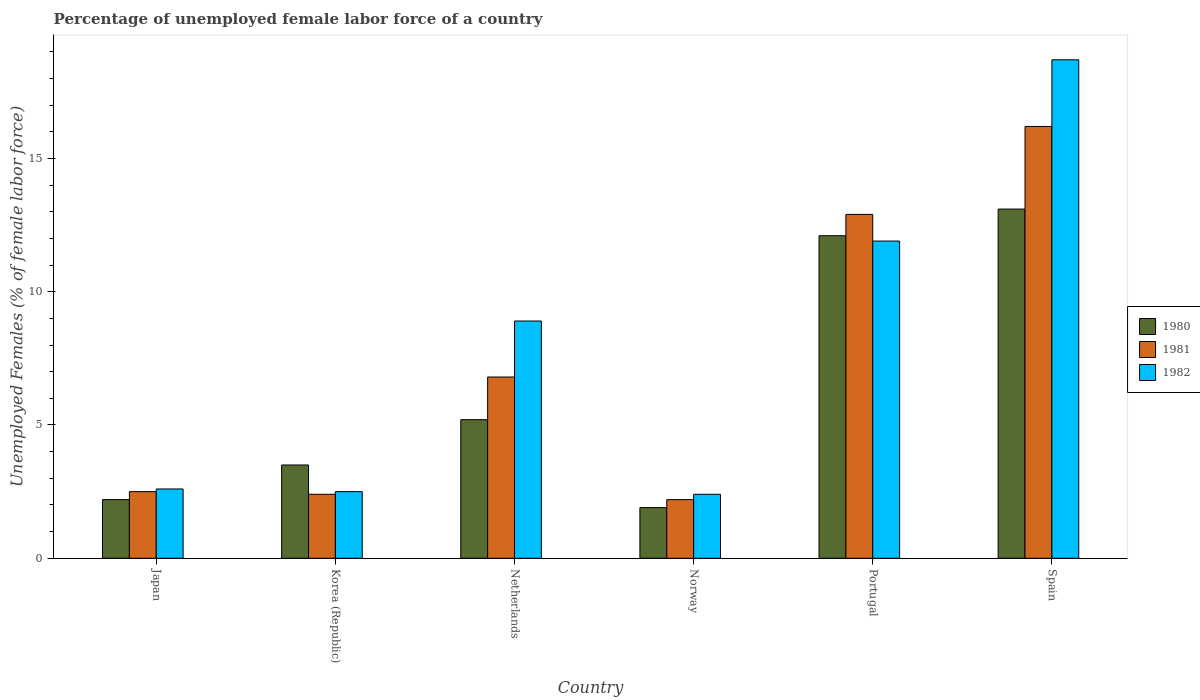Are the number of bars per tick equal to the number of legend labels?
Provide a short and direct response. Yes. How many bars are there on the 4th tick from the left?
Ensure brevity in your answer.  3. How many bars are there on the 4th tick from the right?
Offer a very short reply. 3. What is the label of the 2nd group of bars from the left?
Your response must be concise. Korea (Republic). What is the percentage of unemployed female labor force in 1980 in Spain?
Your answer should be very brief. 13.1. Across all countries, what is the maximum percentage of unemployed female labor force in 1982?
Your answer should be very brief. 18.7. Across all countries, what is the minimum percentage of unemployed female labor force in 1982?
Offer a terse response. 2.4. What is the total percentage of unemployed female labor force in 1980 in the graph?
Give a very brief answer. 38. What is the difference between the percentage of unemployed female labor force in 1982 in Korea (Republic) and that in Norway?
Your response must be concise. 0.1. What is the difference between the percentage of unemployed female labor force in 1981 in Spain and the percentage of unemployed female labor force in 1982 in Netherlands?
Make the answer very short. 7.3. What is the average percentage of unemployed female labor force in 1980 per country?
Your answer should be very brief. 6.33. What is the difference between the percentage of unemployed female labor force of/in 1980 and percentage of unemployed female labor force of/in 1982 in Norway?
Give a very brief answer. -0.5. In how many countries, is the percentage of unemployed female labor force in 1981 greater than 15 %?
Your answer should be very brief. 1. What is the ratio of the percentage of unemployed female labor force in 1980 in Japan to that in Netherlands?
Make the answer very short. 0.42. Is the percentage of unemployed female labor force in 1982 in Korea (Republic) less than that in Netherlands?
Offer a very short reply. Yes. Is the difference between the percentage of unemployed female labor force in 1980 in Korea (Republic) and Portugal greater than the difference between the percentage of unemployed female labor force in 1982 in Korea (Republic) and Portugal?
Offer a very short reply. Yes. What is the difference between the highest and the second highest percentage of unemployed female labor force in 1980?
Offer a terse response. -6.9. What is the difference between the highest and the lowest percentage of unemployed female labor force in 1981?
Provide a succinct answer. 14. In how many countries, is the percentage of unemployed female labor force in 1981 greater than the average percentage of unemployed female labor force in 1981 taken over all countries?
Make the answer very short. 2. Is the sum of the percentage of unemployed female labor force in 1981 in Norway and Portugal greater than the maximum percentage of unemployed female labor force in 1980 across all countries?
Provide a short and direct response. Yes. What does the 3rd bar from the left in Norway represents?
Make the answer very short. 1982. How many bars are there?
Your response must be concise. 18. How many countries are there in the graph?
Provide a succinct answer. 6. What is the difference between two consecutive major ticks on the Y-axis?
Offer a terse response. 5. Does the graph contain grids?
Your response must be concise. No. Where does the legend appear in the graph?
Offer a very short reply. Center right. What is the title of the graph?
Your answer should be very brief. Percentage of unemployed female labor force of a country. What is the label or title of the X-axis?
Provide a short and direct response. Country. What is the label or title of the Y-axis?
Keep it short and to the point. Unemployed Females (% of female labor force). What is the Unemployed Females (% of female labor force) in 1980 in Japan?
Your answer should be very brief. 2.2. What is the Unemployed Females (% of female labor force) of 1981 in Japan?
Make the answer very short. 2.5. What is the Unemployed Females (% of female labor force) in 1982 in Japan?
Your answer should be very brief. 2.6. What is the Unemployed Females (% of female labor force) of 1981 in Korea (Republic)?
Your response must be concise. 2.4. What is the Unemployed Females (% of female labor force) in 1980 in Netherlands?
Ensure brevity in your answer.  5.2. What is the Unemployed Females (% of female labor force) in 1981 in Netherlands?
Your answer should be very brief. 6.8. What is the Unemployed Females (% of female labor force) of 1982 in Netherlands?
Keep it short and to the point. 8.9. What is the Unemployed Females (% of female labor force) of 1980 in Norway?
Provide a succinct answer. 1.9. What is the Unemployed Females (% of female labor force) in 1981 in Norway?
Offer a very short reply. 2.2. What is the Unemployed Females (% of female labor force) of 1982 in Norway?
Offer a terse response. 2.4. What is the Unemployed Females (% of female labor force) of 1980 in Portugal?
Make the answer very short. 12.1. What is the Unemployed Females (% of female labor force) of 1981 in Portugal?
Make the answer very short. 12.9. What is the Unemployed Females (% of female labor force) of 1982 in Portugal?
Offer a very short reply. 11.9. What is the Unemployed Females (% of female labor force) of 1980 in Spain?
Your answer should be compact. 13.1. What is the Unemployed Females (% of female labor force) of 1981 in Spain?
Ensure brevity in your answer.  16.2. What is the Unemployed Females (% of female labor force) of 1982 in Spain?
Your answer should be very brief. 18.7. Across all countries, what is the maximum Unemployed Females (% of female labor force) of 1980?
Offer a terse response. 13.1. Across all countries, what is the maximum Unemployed Females (% of female labor force) in 1981?
Keep it short and to the point. 16.2. Across all countries, what is the maximum Unemployed Females (% of female labor force) in 1982?
Make the answer very short. 18.7. Across all countries, what is the minimum Unemployed Females (% of female labor force) of 1980?
Give a very brief answer. 1.9. Across all countries, what is the minimum Unemployed Females (% of female labor force) in 1981?
Your answer should be very brief. 2.2. Across all countries, what is the minimum Unemployed Females (% of female labor force) in 1982?
Your response must be concise. 2.4. What is the total Unemployed Females (% of female labor force) of 1980 in the graph?
Give a very brief answer. 38. What is the total Unemployed Females (% of female labor force) in 1982 in the graph?
Provide a succinct answer. 47. What is the difference between the Unemployed Females (% of female labor force) of 1980 in Japan and that in Korea (Republic)?
Give a very brief answer. -1.3. What is the difference between the Unemployed Females (% of female labor force) in 1981 in Japan and that in Korea (Republic)?
Ensure brevity in your answer.  0.1. What is the difference between the Unemployed Females (% of female labor force) in 1980 in Japan and that in Netherlands?
Offer a very short reply. -3. What is the difference between the Unemployed Females (% of female labor force) of 1981 in Japan and that in Netherlands?
Your answer should be compact. -4.3. What is the difference between the Unemployed Females (% of female labor force) in 1982 in Japan and that in Netherlands?
Your answer should be compact. -6.3. What is the difference between the Unemployed Females (% of female labor force) of 1982 in Japan and that in Norway?
Keep it short and to the point. 0.2. What is the difference between the Unemployed Females (% of female labor force) in 1981 in Japan and that in Portugal?
Offer a terse response. -10.4. What is the difference between the Unemployed Females (% of female labor force) in 1981 in Japan and that in Spain?
Offer a terse response. -13.7. What is the difference between the Unemployed Females (% of female labor force) in 1982 in Japan and that in Spain?
Ensure brevity in your answer.  -16.1. What is the difference between the Unemployed Females (% of female labor force) of 1980 in Korea (Republic) and that in Netherlands?
Make the answer very short. -1.7. What is the difference between the Unemployed Females (% of female labor force) of 1982 in Korea (Republic) and that in Netherlands?
Ensure brevity in your answer.  -6.4. What is the difference between the Unemployed Females (% of female labor force) in 1980 in Korea (Republic) and that in Norway?
Your response must be concise. 1.6. What is the difference between the Unemployed Females (% of female labor force) in 1981 in Korea (Republic) and that in Norway?
Your answer should be very brief. 0.2. What is the difference between the Unemployed Females (% of female labor force) of 1982 in Korea (Republic) and that in Norway?
Offer a terse response. 0.1. What is the difference between the Unemployed Females (% of female labor force) in 1980 in Korea (Republic) and that in Portugal?
Give a very brief answer. -8.6. What is the difference between the Unemployed Females (% of female labor force) of 1982 in Korea (Republic) and that in Portugal?
Ensure brevity in your answer.  -9.4. What is the difference between the Unemployed Females (% of female labor force) in 1980 in Korea (Republic) and that in Spain?
Offer a very short reply. -9.6. What is the difference between the Unemployed Females (% of female labor force) in 1981 in Korea (Republic) and that in Spain?
Provide a succinct answer. -13.8. What is the difference between the Unemployed Females (% of female labor force) in 1982 in Korea (Republic) and that in Spain?
Your response must be concise. -16.2. What is the difference between the Unemployed Females (% of female labor force) of 1980 in Netherlands and that in Norway?
Keep it short and to the point. 3.3. What is the difference between the Unemployed Females (% of female labor force) of 1982 in Netherlands and that in Norway?
Provide a succinct answer. 6.5. What is the difference between the Unemployed Females (% of female labor force) in 1980 in Netherlands and that in Portugal?
Keep it short and to the point. -6.9. What is the difference between the Unemployed Females (% of female labor force) of 1980 in Netherlands and that in Spain?
Your answer should be compact. -7.9. What is the difference between the Unemployed Females (% of female labor force) of 1981 in Netherlands and that in Spain?
Ensure brevity in your answer.  -9.4. What is the difference between the Unemployed Females (% of female labor force) of 1982 in Netherlands and that in Spain?
Provide a succinct answer. -9.8. What is the difference between the Unemployed Females (% of female labor force) in 1982 in Norway and that in Spain?
Keep it short and to the point. -16.3. What is the difference between the Unemployed Females (% of female labor force) in 1980 in Portugal and that in Spain?
Your answer should be very brief. -1. What is the difference between the Unemployed Females (% of female labor force) in 1981 in Portugal and that in Spain?
Provide a succinct answer. -3.3. What is the difference between the Unemployed Females (% of female labor force) of 1980 in Japan and the Unemployed Females (% of female labor force) of 1981 in Korea (Republic)?
Your answer should be compact. -0.2. What is the difference between the Unemployed Females (% of female labor force) of 1980 in Japan and the Unemployed Females (% of female labor force) of 1982 in Korea (Republic)?
Your response must be concise. -0.3. What is the difference between the Unemployed Females (% of female labor force) in 1980 in Japan and the Unemployed Females (% of female labor force) in 1981 in Norway?
Ensure brevity in your answer.  0. What is the difference between the Unemployed Females (% of female labor force) in 1980 in Japan and the Unemployed Females (% of female labor force) in 1982 in Norway?
Give a very brief answer. -0.2. What is the difference between the Unemployed Females (% of female labor force) of 1981 in Japan and the Unemployed Females (% of female labor force) of 1982 in Norway?
Provide a succinct answer. 0.1. What is the difference between the Unemployed Females (% of female labor force) in 1980 in Japan and the Unemployed Females (% of female labor force) in 1981 in Portugal?
Give a very brief answer. -10.7. What is the difference between the Unemployed Females (% of female labor force) of 1980 in Japan and the Unemployed Females (% of female labor force) of 1982 in Portugal?
Offer a terse response. -9.7. What is the difference between the Unemployed Females (% of female labor force) in 1980 in Japan and the Unemployed Females (% of female labor force) in 1981 in Spain?
Your answer should be compact. -14. What is the difference between the Unemployed Females (% of female labor force) in 1980 in Japan and the Unemployed Females (% of female labor force) in 1982 in Spain?
Ensure brevity in your answer.  -16.5. What is the difference between the Unemployed Females (% of female labor force) in 1981 in Japan and the Unemployed Females (% of female labor force) in 1982 in Spain?
Your answer should be very brief. -16.2. What is the difference between the Unemployed Females (% of female labor force) in 1980 in Korea (Republic) and the Unemployed Females (% of female labor force) in 1982 in Netherlands?
Your response must be concise. -5.4. What is the difference between the Unemployed Females (% of female labor force) in 1981 in Korea (Republic) and the Unemployed Females (% of female labor force) in 1982 in Netherlands?
Offer a very short reply. -6.5. What is the difference between the Unemployed Females (% of female labor force) in 1980 in Korea (Republic) and the Unemployed Females (% of female labor force) in 1981 in Norway?
Make the answer very short. 1.3. What is the difference between the Unemployed Females (% of female labor force) in 1981 in Korea (Republic) and the Unemployed Females (% of female labor force) in 1982 in Norway?
Keep it short and to the point. 0. What is the difference between the Unemployed Females (% of female labor force) of 1980 in Korea (Republic) and the Unemployed Females (% of female labor force) of 1981 in Spain?
Your response must be concise. -12.7. What is the difference between the Unemployed Females (% of female labor force) in 1980 in Korea (Republic) and the Unemployed Females (% of female labor force) in 1982 in Spain?
Offer a very short reply. -15.2. What is the difference between the Unemployed Females (% of female labor force) in 1981 in Korea (Republic) and the Unemployed Females (% of female labor force) in 1982 in Spain?
Offer a terse response. -16.3. What is the difference between the Unemployed Females (% of female labor force) in 1980 in Netherlands and the Unemployed Females (% of female labor force) in 1982 in Norway?
Keep it short and to the point. 2.8. What is the difference between the Unemployed Females (% of female labor force) of 1981 in Netherlands and the Unemployed Females (% of female labor force) of 1982 in Norway?
Make the answer very short. 4.4. What is the difference between the Unemployed Females (% of female labor force) in 1980 in Netherlands and the Unemployed Females (% of female labor force) in 1981 in Portugal?
Give a very brief answer. -7.7. What is the difference between the Unemployed Females (% of female labor force) of 1981 in Netherlands and the Unemployed Females (% of female labor force) of 1982 in Portugal?
Make the answer very short. -5.1. What is the difference between the Unemployed Females (% of female labor force) in 1980 in Norway and the Unemployed Females (% of female labor force) in 1981 in Portugal?
Give a very brief answer. -11. What is the difference between the Unemployed Females (% of female labor force) in 1980 in Norway and the Unemployed Females (% of female labor force) in 1982 in Portugal?
Give a very brief answer. -10. What is the difference between the Unemployed Females (% of female labor force) of 1981 in Norway and the Unemployed Females (% of female labor force) of 1982 in Portugal?
Offer a very short reply. -9.7. What is the difference between the Unemployed Females (% of female labor force) in 1980 in Norway and the Unemployed Females (% of female labor force) in 1981 in Spain?
Your answer should be very brief. -14.3. What is the difference between the Unemployed Females (% of female labor force) of 1980 in Norway and the Unemployed Females (% of female labor force) of 1982 in Spain?
Provide a succinct answer. -16.8. What is the difference between the Unemployed Females (% of female labor force) of 1981 in Norway and the Unemployed Females (% of female labor force) of 1982 in Spain?
Your answer should be very brief. -16.5. What is the difference between the Unemployed Females (% of female labor force) in 1980 in Portugal and the Unemployed Females (% of female labor force) in 1982 in Spain?
Provide a succinct answer. -6.6. What is the difference between the Unemployed Females (% of female labor force) in 1981 in Portugal and the Unemployed Females (% of female labor force) in 1982 in Spain?
Your answer should be very brief. -5.8. What is the average Unemployed Females (% of female labor force) in 1980 per country?
Provide a short and direct response. 6.33. What is the average Unemployed Females (% of female labor force) in 1981 per country?
Provide a succinct answer. 7.17. What is the average Unemployed Females (% of female labor force) in 1982 per country?
Offer a very short reply. 7.83. What is the difference between the Unemployed Females (% of female labor force) in 1980 and Unemployed Females (% of female labor force) in 1982 in Japan?
Offer a terse response. -0.4. What is the difference between the Unemployed Females (% of female labor force) in 1981 and Unemployed Females (% of female labor force) in 1982 in Japan?
Offer a terse response. -0.1. What is the difference between the Unemployed Females (% of female labor force) in 1980 and Unemployed Females (% of female labor force) in 1981 in Korea (Republic)?
Offer a very short reply. 1.1. What is the difference between the Unemployed Females (% of female labor force) in 1980 and Unemployed Females (% of female labor force) in 1981 in Netherlands?
Make the answer very short. -1.6. What is the difference between the Unemployed Females (% of female labor force) in 1980 and Unemployed Females (% of female labor force) in 1982 in Netherlands?
Keep it short and to the point. -3.7. What is the difference between the Unemployed Females (% of female labor force) of 1981 and Unemployed Females (% of female labor force) of 1982 in Netherlands?
Your answer should be compact. -2.1. What is the difference between the Unemployed Females (% of female labor force) of 1980 and Unemployed Females (% of female labor force) of 1981 in Portugal?
Provide a succinct answer. -0.8. What is the ratio of the Unemployed Females (% of female labor force) in 1980 in Japan to that in Korea (Republic)?
Give a very brief answer. 0.63. What is the ratio of the Unemployed Females (% of female labor force) of 1981 in Japan to that in Korea (Republic)?
Your response must be concise. 1.04. What is the ratio of the Unemployed Females (% of female labor force) of 1982 in Japan to that in Korea (Republic)?
Your answer should be very brief. 1.04. What is the ratio of the Unemployed Females (% of female labor force) of 1980 in Japan to that in Netherlands?
Keep it short and to the point. 0.42. What is the ratio of the Unemployed Females (% of female labor force) in 1981 in Japan to that in Netherlands?
Provide a short and direct response. 0.37. What is the ratio of the Unemployed Females (% of female labor force) of 1982 in Japan to that in Netherlands?
Your response must be concise. 0.29. What is the ratio of the Unemployed Females (% of female labor force) in 1980 in Japan to that in Norway?
Keep it short and to the point. 1.16. What is the ratio of the Unemployed Females (% of female labor force) of 1981 in Japan to that in Norway?
Make the answer very short. 1.14. What is the ratio of the Unemployed Females (% of female labor force) of 1982 in Japan to that in Norway?
Your answer should be compact. 1.08. What is the ratio of the Unemployed Females (% of female labor force) of 1980 in Japan to that in Portugal?
Keep it short and to the point. 0.18. What is the ratio of the Unemployed Females (% of female labor force) in 1981 in Japan to that in Portugal?
Provide a short and direct response. 0.19. What is the ratio of the Unemployed Females (% of female labor force) in 1982 in Japan to that in Portugal?
Provide a short and direct response. 0.22. What is the ratio of the Unemployed Females (% of female labor force) of 1980 in Japan to that in Spain?
Ensure brevity in your answer.  0.17. What is the ratio of the Unemployed Females (% of female labor force) of 1981 in Japan to that in Spain?
Provide a succinct answer. 0.15. What is the ratio of the Unemployed Females (% of female labor force) of 1982 in Japan to that in Spain?
Your answer should be very brief. 0.14. What is the ratio of the Unemployed Females (% of female labor force) in 1980 in Korea (Republic) to that in Netherlands?
Your response must be concise. 0.67. What is the ratio of the Unemployed Females (% of female labor force) of 1981 in Korea (Republic) to that in Netherlands?
Your answer should be compact. 0.35. What is the ratio of the Unemployed Females (% of female labor force) in 1982 in Korea (Republic) to that in Netherlands?
Ensure brevity in your answer.  0.28. What is the ratio of the Unemployed Females (% of female labor force) in 1980 in Korea (Republic) to that in Norway?
Ensure brevity in your answer.  1.84. What is the ratio of the Unemployed Females (% of female labor force) in 1982 in Korea (Republic) to that in Norway?
Your answer should be very brief. 1.04. What is the ratio of the Unemployed Females (% of female labor force) of 1980 in Korea (Republic) to that in Portugal?
Offer a very short reply. 0.29. What is the ratio of the Unemployed Females (% of female labor force) in 1981 in Korea (Republic) to that in Portugal?
Provide a short and direct response. 0.19. What is the ratio of the Unemployed Females (% of female labor force) in 1982 in Korea (Republic) to that in Portugal?
Your answer should be very brief. 0.21. What is the ratio of the Unemployed Females (% of female labor force) in 1980 in Korea (Republic) to that in Spain?
Provide a short and direct response. 0.27. What is the ratio of the Unemployed Females (% of female labor force) of 1981 in Korea (Republic) to that in Spain?
Provide a short and direct response. 0.15. What is the ratio of the Unemployed Females (% of female labor force) of 1982 in Korea (Republic) to that in Spain?
Provide a succinct answer. 0.13. What is the ratio of the Unemployed Females (% of female labor force) in 1980 in Netherlands to that in Norway?
Keep it short and to the point. 2.74. What is the ratio of the Unemployed Females (% of female labor force) in 1981 in Netherlands to that in Norway?
Provide a succinct answer. 3.09. What is the ratio of the Unemployed Females (% of female labor force) in 1982 in Netherlands to that in Norway?
Your answer should be compact. 3.71. What is the ratio of the Unemployed Females (% of female labor force) in 1980 in Netherlands to that in Portugal?
Your response must be concise. 0.43. What is the ratio of the Unemployed Females (% of female labor force) in 1981 in Netherlands to that in Portugal?
Ensure brevity in your answer.  0.53. What is the ratio of the Unemployed Females (% of female labor force) in 1982 in Netherlands to that in Portugal?
Offer a terse response. 0.75. What is the ratio of the Unemployed Females (% of female labor force) of 1980 in Netherlands to that in Spain?
Provide a succinct answer. 0.4. What is the ratio of the Unemployed Females (% of female labor force) in 1981 in Netherlands to that in Spain?
Offer a terse response. 0.42. What is the ratio of the Unemployed Females (% of female labor force) in 1982 in Netherlands to that in Spain?
Offer a very short reply. 0.48. What is the ratio of the Unemployed Females (% of female labor force) in 1980 in Norway to that in Portugal?
Provide a succinct answer. 0.16. What is the ratio of the Unemployed Females (% of female labor force) of 1981 in Norway to that in Portugal?
Give a very brief answer. 0.17. What is the ratio of the Unemployed Females (% of female labor force) of 1982 in Norway to that in Portugal?
Make the answer very short. 0.2. What is the ratio of the Unemployed Females (% of female labor force) in 1980 in Norway to that in Spain?
Your answer should be very brief. 0.14. What is the ratio of the Unemployed Females (% of female labor force) of 1981 in Norway to that in Spain?
Keep it short and to the point. 0.14. What is the ratio of the Unemployed Females (% of female labor force) of 1982 in Norway to that in Spain?
Offer a very short reply. 0.13. What is the ratio of the Unemployed Females (% of female labor force) of 1980 in Portugal to that in Spain?
Your answer should be compact. 0.92. What is the ratio of the Unemployed Females (% of female labor force) in 1981 in Portugal to that in Spain?
Your answer should be very brief. 0.8. What is the ratio of the Unemployed Females (% of female labor force) in 1982 in Portugal to that in Spain?
Your answer should be compact. 0.64. What is the difference between the highest and the second highest Unemployed Females (% of female labor force) of 1980?
Give a very brief answer. 1. What is the difference between the highest and the lowest Unemployed Females (% of female labor force) in 1980?
Your answer should be compact. 11.2. 